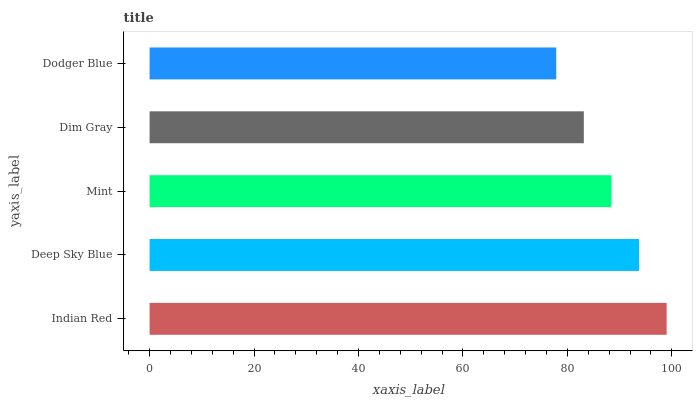Is Dodger Blue the minimum?
Answer yes or no. Yes. Is Indian Red the maximum?
Answer yes or no. Yes. Is Deep Sky Blue the minimum?
Answer yes or no. No. Is Deep Sky Blue the maximum?
Answer yes or no. No. Is Indian Red greater than Deep Sky Blue?
Answer yes or no. Yes. Is Deep Sky Blue less than Indian Red?
Answer yes or no. Yes. Is Deep Sky Blue greater than Indian Red?
Answer yes or no. No. Is Indian Red less than Deep Sky Blue?
Answer yes or no. No. Is Mint the high median?
Answer yes or no. Yes. Is Mint the low median?
Answer yes or no. Yes. Is Indian Red the high median?
Answer yes or no. No. Is Deep Sky Blue the low median?
Answer yes or no. No. 